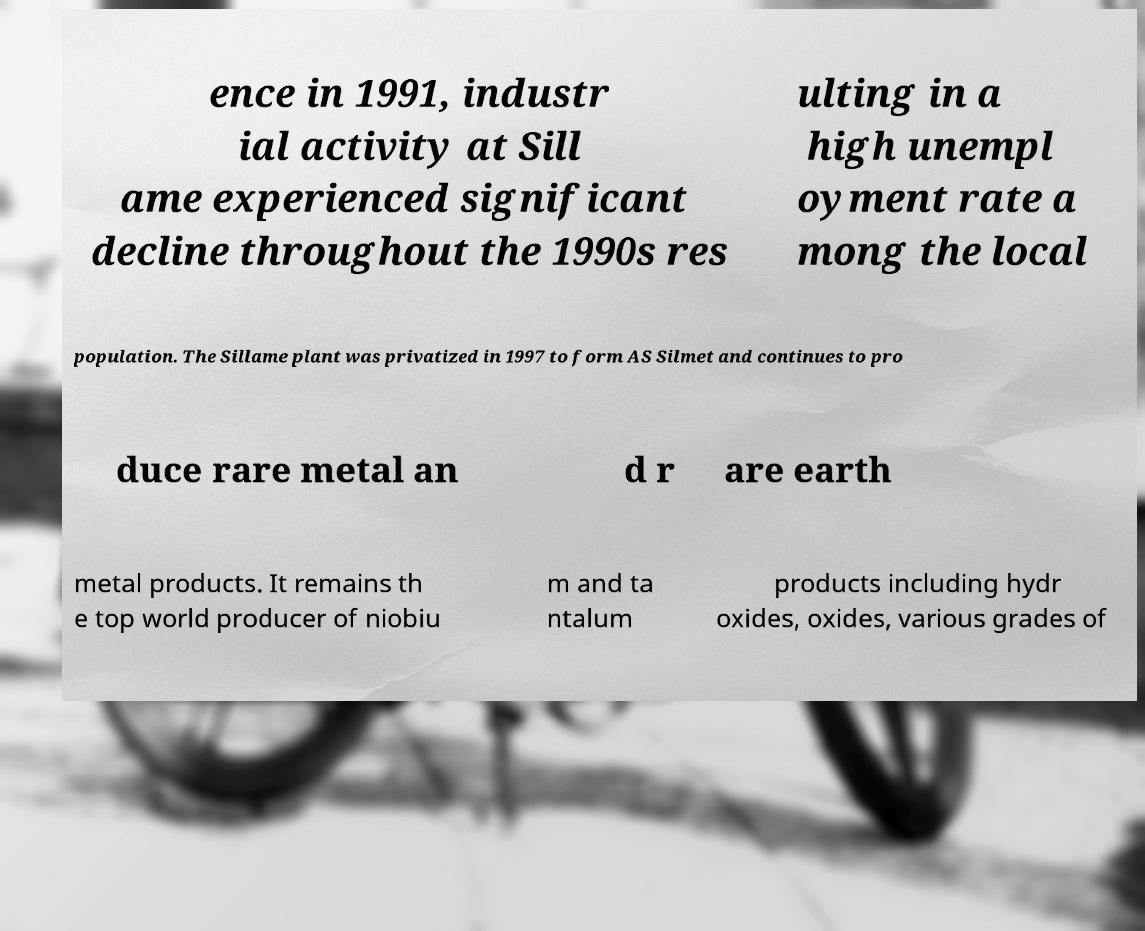Please read and relay the text visible in this image. What does it say? ence in 1991, industr ial activity at Sill ame experienced significant decline throughout the 1990s res ulting in a high unempl oyment rate a mong the local population. The Sillame plant was privatized in 1997 to form AS Silmet and continues to pro duce rare metal an d r are earth metal products. It remains th e top world producer of niobiu m and ta ntalum products including hydr oxides, oxides, various grades of 